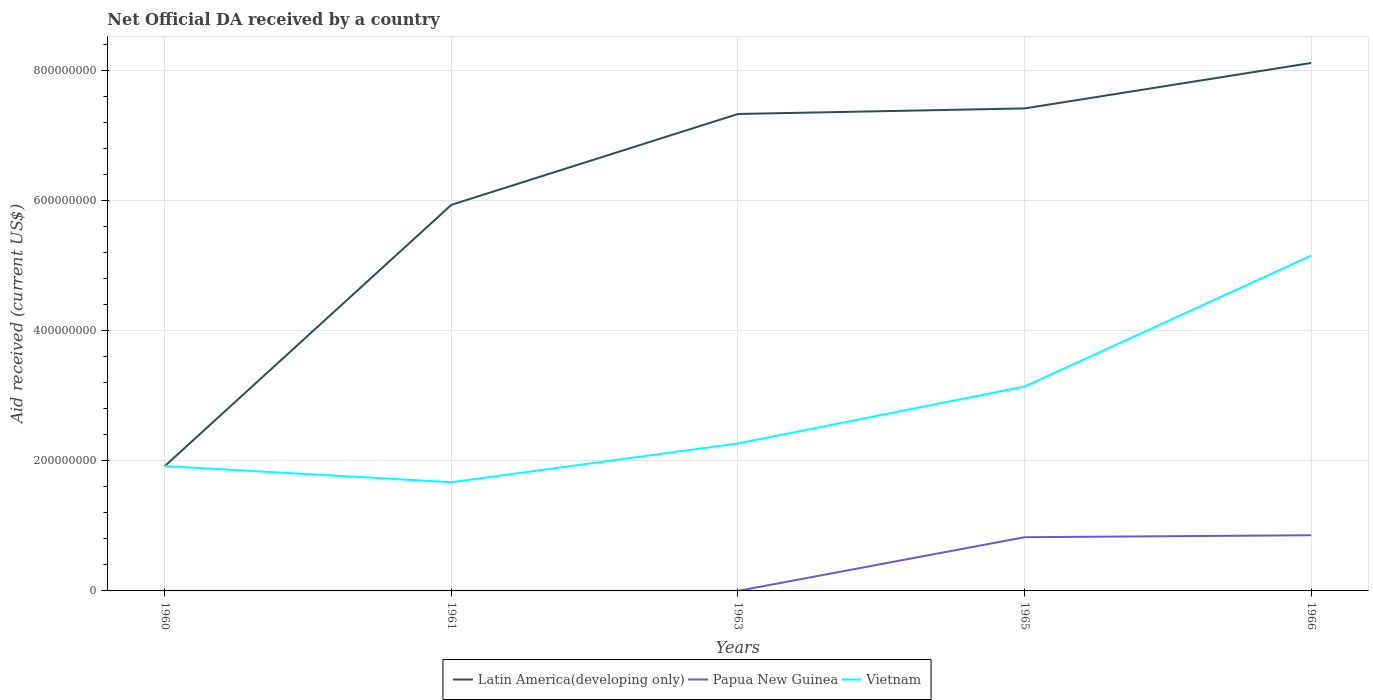Does the line corresponding to Vietnam intersect with the line corresponding to Latin America(developing only)?
Your answer should be very brief. No. Is the number of lines equal to the number of legend labels?
Make the answer very short. Yes. Across all years, what is the maximum net official development assistance aid received in Latin America(developing only)?
Your answer should be compact. 1.92e+08. In which year was the net official development assistance aid received in Papua New Guinea maximum?
Offer a very short reply. 1960. What is the total net official development assistance aid received in Latin America(developing only) in the graph?
Provide a succinct answer. -7.84e+07. What is the difference between the highest and the second highest net official development assistance aid received in Latin America(developing only)?
Give a very brief answer. 6.20e+08. What is the difference between the highest and the lowest net official development assistance aid received in Vietnam?
Your answer should be compact. 2. How many years are there in the graph?
Offer a very short reply. 5. What is the difference between two consecutive major ticks on the Y-axis?
Your response must be concise. 2.00e+08. Does the graph contain grids?
Provide a short and direct response. Yes. Where does the legend appear in the graph?
Your answer should be compact. Bottom center. How are the legend labels stacked?
Your response must be concise. Horizontal. What is the title of the graph?
Ensure brevity in your answer.  Net Official DA received by a country. What is the label or title of the X-axis?
Keep it short and to the point. Years. What is the label or title of the Y-axis?
Offer a terse response. Aid received (current US$). What is the Aid received (current US$) of Latin America(developing only) in 1960?
Make the answer very short. 1.92e+08. What is the Aid received (current US$) of Papua New Guinea in 1960?
Give a very brief answer. 10000. What is the Aid received (current US$) of Vietnam in 1960?
Provide a succinct answer. 1.92e+08. What is the Aid received (current US$) of Latin America(developing only) in 1961?
Your answer should be compact. 5.93e+08. What is the Aid received (current US$) of Papua New Guinea in 1961?
Your answer should be very brief. 10000. What is the Aid received (current US$) in Vietnam in 1961?
Your response must be concise. 1.67e+08. What is the Aid received (current US$) of Latin America(developing only) in 1963?
Your answer should be very brief. 7.33e+08. What is the Aid received (current US$) of Papua New Guinea in 1963?
Provide a succinct answer. 10000. What is the Aid received (current US$) in Vietnam in 1963?
Make the answer very short. 2.27e+08. What is the Aid received (current US$) of Latin America(developing only) in 1965?
Give a very brief answer. 7.42e+08. What is the Aid received (current US$) in Papua New Guinea in 1965?
Offer a very short reply. 8.26e+07. What is the Aid received (current US$) in Vietnam in 1965?
Your answer should be very brief. 3.14e+08. What is the Aid received (current US$) of Latin America(developing only) in 1966?
Your response must be concise. 8.12e+08. What is the Aid received (current US$) of Papua New Guinea in 1966?
Ensure brevity in your answer.  8.56e+07. What is the Aid received (current US$) of Vietnam in 1966?
Offer a very short reply. 5.15e+08. Across all years, what is the maximum Aid received (current US$) of Latin America(developing only)?
Keep it short and to the point. 8.12e+08. Across all years, what is the maximum Aid received (current US$) in Papua New Guinea?
Offer a very short reply. 8.56e+07. Across all years, what is the maximum Aid received (current US$) in Vietnam?
Your answer should be compact. 5.15e+08. Across all years, what is the minimum Aid received (current US$) in Latin America(developing only)?
Your answer should be very brief. 1.92e+08. Across all years, what is the minimum Aid received (current US$) in Papua New Guinea?
Your answer should be very brief. 10000. Across all years, what is the minimum Aid received (current US$) of Vietnam?
Provide a short and direct response. 1.67e+08. What is the total Aid received (current US$) in Latin America(developing only) in the graph?
Offer a terse response. 3.07e+09. What is the total Aid received (current US$) in Papua New Guinea in the graph?
Give a very brief answer. 1.68e+08. What is the total Aid received (current US$) of Vietnam in the graph?
Give a very brief answer. 1.42e+09. What is the difference between the Aid received (current US$) of Latin America(developing only) in 1960 and that in 1961?
Provide a short and direct response. -4.02e+08. What is the difference between the Aid received (current US$) of Vietnam in 1960 and that in 1961?
Offer a terse response. 2.47e+07. What is the difference between the Aid received (current US$) in Latin America(developing only) in 1960 and that in 1963?
Your response must be concise. -5.41e+08. What is the difference between the Aid received (current US$) of Papua New Guinea in 1960 and that in 1963?
Make the answer very short. 0. What is the difference between the Aid received (current US$) in Vietnam in 1960 and that in 1963?
Your answer should be very brief. -3.48e+07. What is the difference between the Aid received (current US$) of Latin America(developing only) in 1960 and that in 1965?
Give a very brief answer. -5.50e+08. What is the difference between the Aid received (current US$) in Papua New Guinea in 1960 and that in 1965?
Provide a short and direct response. -8.26e+07. What is the difference between the Aid received (current US$) of Vietnam in 1960 and that in 1965?
Offer a terse response. -1.22e+08. What is the difference between the Aid received (current US$) of Latin America(developing only) in 1960 and that in 1966?
Provide a short and direct response. -6.20e+08. What is the difference between the Aid received (current US$) of Papua New Guinea in 1960 and that in 1966?
Offer a terse response. -8.56e+07. What is the difference between the Aid received (current US$) of Vietnam in 1960 and that in 1966?
Keep it short and to the point. -3.24e+08. What is the difference between the Aid received (current US$) in Latin America(developing only) in 1961 and that in 1963?
Ensure brevity in your answer.  -1.40e+08. What is the difference between the Aid received (current US$) of Papua New Guinea in 1961 and that in 1963?
Offer a terse response. 0. What is the difference between the Aid received (current US$) in Vietnam in 1961 and that in 1963?
Offer a very short reply. -5.96e+07. What is the difference between the Aid received (current US$) in Latin America(developing only) in 1961 and that in 1965?
Your answer should be compact. -1.48e+08. What is the difference between the Aid received (current US$) of Papua New Guinea in 1961 and that in 1965?
Your response must be concise. -8.26e+07. What is the difference between the Aid received (current US$) of Vietnam in 1961 and that in 1965?
Give a very brief answer. -1.47e+08. What is the difference between the Aid received (current US$) in Latin America(developing only) in 1961 and that in 1966?
Make the answer very short. -2.18e+08. What is the difference between the Aid received (current US$) in Papua New Guinea in 1961 and that in 1966?
Provide a succinct answer. -8.56e+07. What is the difference between the Aid received (current US$) in Vietnam in 1961 and that in 1966?
Your answer should be compact. -3.48e+08. What is the difference between the Aid received (current US$) of Latin America(developing only) in 1963 and that in 1965?
Keep it short and to the point. -8.56e+06. What is the difference between the Aid received (current US$) of Papua New Guinea in 1963 and that in 1965?
Offer a terse response. -8.26e+07. What is the difference between the Aid received (current US$) in Vietnam in 1963 and that in 1965?
Offer a terse response. -8.75e+07. What is the difference between the Aid received (current US$) in Latin America(developing only) in 1963 and that in 1966?
Your answer should be very brief. -7.84e+07. What is the difference between the Aid received (current US$) in Papua New Guinea in 1963 and that in 1966?
Make the answer very short. -8.56e+07. What is the difference between the Aid received (current US$) of Vietnam in 1963 and that in 1966?
Your answer should be very brief. -2.89e+08. What is the difference between the Aid received (current US$) of Latin America(developing only) in 1965 and that in 1966?
Offer a terse response. -6.98e+07. What is the difference between the Aid received (current US$) of Papua New Guinea in 1965 and that in 1966?
Provide a short and direct response. -3.03e+06. What is the difference between the Aid received (current US$) in Vietnam in 1965 and that in 1966?
Provide a short and direct response. -2.01e+08. What is the difference between the Aid received (current US$) in Latin America(developing only) in 1960 and the Aid received (current US$) in Papua New Guinea in 1961?
Give a very brief answer. 1.92e+08. What is the difference between the Aid received (current US$) in Latin America(developing only) in 1960 and the Aid received (current US$) in Vietnam in 1961?
Offer a terse response. 2.48e+07. What is the difference between the Aid received (current US$) in Papua New Guinea in 1960 and the Aid received (current US$) in Vietnam in 1961?
Your answer should be very brief. -1.67e+08. What is the difference between the Aid received (current US$) in Latin America(developing only) in 1960 and the Aid received (current US$) in Papua New Guinea in 1963?
Your response must be concise. 1.92e+08. What is the difference between the Aid received (current US$) in Latin America(developing only) in 1960 and the Aid received (current US$) in Vietnam in 1963?
Give a very brief answer. -3.48e+07. What is the difference between the Aid received (current US$) of Papua New Guinea in 1960 and the Aid received (current US$) of Vietnam in 1963?
Offer a terse response. -2.27e+08. What is the difference between the Aid received (current US$) in Latin America(developing only) in 1960 and the Aid received (current US$) in Papua New Guinea in 1965?
Your response must be concise. 1.09e+08. What is the difference between the Aid received (current US$) of Latin America(developing only) in 1960 and the Aid received (current US$) of Vietnam in 1965?
Ensure brevity in your answer.  -1.22e+08. What is the difference between the Aid received (current US$) in Papua New Guinea in 1960 and the Aid received (current US$) in Vietnam in 1965?
Make the answer very short. -3.14e+08. What is the difference between the Aid received (current US$) of Latin America(developing only) in 1960 and the Aid received (current US$) of Papua New Guinea in 1966?
Provide a succinct answer. 1.06e+08. What is the difference between the Aid received (current US$) in Latin America(developing only) in 1960 and the Aid received (current US$) in Vietnam in 1966?
Offer a terse response. -3.23e+08. What is the difference between the Aid received (current US$) of Papua New Guinea in 1960 and the Aid received (current US$) of Vietnam in 1966?
Provide a succinct answer. -5.15e+08. What is the difference between the Aid received (current US$) in Latin America(developing only) in 1961 and the Aid received (current US$) in Papua New Guinea in 1963?
Your answer should be compact. 5.93e+08. What is the difference between the Aid received (current US$) of Latin America(developing only) in 1961 and the Aid received (current US$) of Vietnam in 1963?
Your answer should be compact. 3.67e+08. What is the difference between the Aid received (current US$) in Papua New Guinea in 1961 and the Aid received (current US$) in Vietnam in 1963?
Offer a terse response. -2.27e+08. What is the difference between the Aid received (current US$) in Latin America(developing only) in 1961 and the Aid received (current US$) in Papua New Guinea in 1965?
Offer a very short reply. 5.11e+08. What is the difference between the Aid received (current US$) of Latin America(developing only) in 1961 and the Aid received (current US$) of Vietnam in 1965?
Make the answer very short. 2.79e+08. What is the difference between the Aid received (current US$) in Papua New Guinea in 1961 and the Aid received (current US$) in Vietnam in 1965?
Ensure brevity in your answer.  -3.14e+08. What is the difference between the Aid received (current US$) of Latin America(developing only) in 1961 and the Aid received (current US$) of Papua New Guinea in 1966?
Keep it short and to the point. 5.08e+08. What is the difference between the Aid received (current US$) in Latin America(developing only) in 1961 and the Aid received (current US$) in Vietnam in 1966?
Provide a short and direct response. 7.81e+07. What is the difference between the Aid received (current US$) in Papua New Guinea in 1961 and the Aid received (current US$) in Vietnam in 1966?
Offer a terse response. -5.15e+08. What is the difference between the Aid received (current US$) of Latin America(developing only) in 1963 and the Aid received (current US$) of Papua New Guinea in 1965?
Offer a terse response. 6.51e+08. What is the difference between the Aid received (current US$) of Latin America(developing only) in 1963 and the Aid received (current US$) of Vietnam in 1965?
Your answer should be compact. 4.19e+08. What is the difference between the Aid received (current US$) in Papua New Guinea in 1963 and the Aid received (current US$) in Vietnam in 1965?
Give a very brief answer. -3.14e+08. What is the difference between the Aid received (current US$) of Latin America(developing only) in 1963 and the Aid received (current US$) of Papua New Guinea in 1966?
Offer a terse response. 6.48e+08. What is the difference between the Aid received (current US$) of Latin America(developing only) in 1963 and the Aid received (current US$) of Vietnam in 1966?
Offer a terse response. 2.18e+08. What is the difference between the Aid received (current US$) in Papua New Guinea in 1963 and the Aid received (current US$) in Vietnam in 1966?
Your response must be concise. -5.15e+08. What is the difference between the Aid received (current US$) in Latin America(developing only) in 1965 and the Aid received (current US$) in Papua New Guinea in 1966?
Your response must be concise. 6.56e+08. What is the difference between the Aid received (current US$) of Latin America(developing only) in 1965 and the Aid received (current US$) of Vietnam in 1966?
Ensure brevity in your answer.  2.26e+08. What is the difference between the Aid received (current US$) in Papua New Guinea in 1965 and the Aid received (current US$) in Vietnam in 1966?
Offer a very short reply. -4.33e+08. What is the average Aid received (current US$) of Latin America(developing only) per year?
Make the answer very short. 6.14e+08. What is the average Aid received (current US$) in Papua New Guinea per year?
Give a very brief answer. 3.36e+07. What is the average Aid received (current US$) in Vietnam per year?
Make the answer very short. 2.83e+08. In the year 1960, what is the difference between the Aid received (current US$) of Latin America(developing only) and Aid received (current US$) of Papua New Guinea?
Provide a short and direct response. 1.92e+08. In the year 1960, what is the difference between the Aid received (current US$) in Latin America(developing only) and Aid received (current US$) in Vietnam?
Ensure brevity in your answer.  4.00e+04. In the year 1960, what is the difference between the Aid received (current US$) in Papua New Guinea and Aid received (current US$) in Vietnam?
Make the answer very short. -1.92e+08. In the year 1961, what is the difference between the Aid received (current US$) of Latin America(developing only) and Aid received (current US$) of Papua New Guinea?
Make the answer very short. 5.93e+08. In the year 1961, what is the difference between the Aid received (current US$) in Latin America(developing only) and Aid received (current US$) in Vietnam?
Give a very brief answer. 4.26e+08. In the year 1961, what is the difference between the Aid received (current US$) in Papua New Guinea and Aid received (current US$) in Vietnam?
Ensure brevity in your answer.  -1.67e+08. In the year 1963, what is the difference between the Aid received (current US$) of Latin America(developing only) and Aid received (current US$) of Papua New Guinea?
Provide a succinct answer. 7.33e+08. In the year 1963, what is the difference between the Aid received (current US$) of Latin America(developing only) and Aid received (current US$) of Vietnam?
Give a very brief answer. 5.06e+08. In the year 1963, what is the difference between the Aid received (current US$) in Papua New Guinea and Aid received (current US$) in Vietnam?
Provide a short and direct response. -2.27e+08. In the year 1965, what is the difference between the Aid received (current US$) in Latin America(developing only) and Aid received (current US$) in Papua New Guinea?
Provide a short and direct response. 6.59e+08. In the year 1965, what is the difference between the Aid received (current US$) in Latin America(developing only) and Aid received (current US$) in Vietnam?
Offer a terse response. 4.28e+08. In the year 1965, what is the difference between the Aid received (current US$) in Papua New Guinea and Aid received (current US$) in Vietnam?
Provide a short and direct response. -2.32e+08. In the year 1966, what is the difference between the Aid received (current US$) in Latin America(developing only) and Aid received (current US$) in Papua New Guinea?
Make the answer very short. 7.26e+08. In the year 1966, what is the difference between the Aid received (current US$) of Latin America(developing only) and Aid received (current US$) of Vietnam?
Provide a short and direct response. 2.96e+08. In the year 1966, what is the difference between the Aid received (current US$) in Papua New Guinea and Aid received (current US$) in Vietnam?
Ensure brevity in your answer.  -4.30e+08. What is the ratio of the Aid received (current US$) of Latin America(developing only) in 1960 to that in 1961?
Ensure brevity in your answer.  0.32. What is the ratio of the Aid received (current US$) of Papua New Guinea in 1960 to that in 1961?
Provide a succinct answer. 1. What is the ratio of the Aid received (current US$) of Vietnam in 1960 to that in 1961?
Provide a short and direct response. 1.15. What is the ratio of the Aid received (current US$) in Latin America(developing only) in 1960 to that in 1963?
Keep it short and to the point. 0.26. What is the ratio of the Aid received (current US$) in Papua New Guinea in 1960 to that in 1963?
Make the answer very short. 1. What is the ratio of the Aid received (current US$) in Vietnam in 1960 to that in 1963?
Your answer should be very brief. 0.85. What is the ratio of the Aid received (current US$) of Latin America(developing only) in 1960 to that in 1965?
Offer a very short reply. 0.26. What is the ratio of the Aid received (current US$) of Vietnam in 1960 to that in 1965?
Provide a short and direct response. 0.61. What is the ratio of the Aid received (current US$) of Latin America(developing only) in 1960 to that in 1966?
Offer a terse response. 0.24. What is the ratio of the Aid received (current US$) of Vietnam in 1960 to that in 1966?
Provide a succinct answer. 0.37. What is the ratio of the Aid received (current US$) in Latin America(developing only) in 1961 to that in 1963?
Make the answer very short. 0.81. What is the ratio of the Aid received (current US$) of Papua New Guinea in 1961 to that in 1963?
Ensure brevity in your answer.  1. What is the ratio of the Aid received (current US$) in Vietnam in 1961 to that in 1963?
Ensure brevity in your answer.  0.74. What is the ratio of the Aid received (current US$) of Latin America(developing only) in 1961 to that in 1965?
Provide a short and direct response. 0.8. What is the ratio of the Aid received (current US$) in Vietnam in 1961 to that in 1965?
Give a very brief answer. 0.53. What is the ratio of the Aid received (current US$) of Latin America(developing only) in 1961 to that in 1966?
Your answer should be compact. 0.73. What is the ratio of the Aid received (current US$) in Papua New Guinea in 1961 to that in 1966?
Provide a short and direct response. 0. What is the ratio of the Aid received (current US$) of Vietnam in 1961 to that in 1966?
Offer a very short reply. 0.32. What is the ratio of the Aid received (current US$) in Vietnam in 1963 to that in 1965?
Offer a very short reply. 0.72. What is the ratio of the Aid received (current US$) in Latin America(developing only) in 1963 to that in 1966?
Ensure brevity in your answer.  0.9. What is the ratio of the Aid received (current US$) in Vietnam in 1963 to that in 1966?
Offer a very short reply. 0.44. What is the ratio of the Aid received (current US$) in Latin America(developing only) in 1965 to that in 1966?
Your answer should be compact. 0.91. What is the ratio of the Aid received (current US$) of Papua New Guinea in 1965 to that in 1966?
Make the answer very short. 0.96. What is the ratio of the Aid received (current US$) in Vietnam in 1965 to that in 1966?
Offer a terse response. 0.61. What is the difference between the highest and the second highest Aid received (current US$) in Latin America(developing only)?
Provide a short and direct response. 6.98e+07. What is the difference between the highest and the second highest Aid received (current US$) of Papua New Guinea?
Your answer should be compact. 3.03e+06. What is the difference between the highest and the second highest Aid received (current US$) in Vietnam?
Your response must be concise. 2.01e+08. What is the difference between the highest and the lowest Aid received (current US$) in Latin America(developing only)?
Provide a succinct answer. 6.20e+08. What is the difference between the highest and the lowest Aid received (current US$) of Papua New Guinea?
Provide a short and direct response. 8.56e+07. What is the difference between the highest and the lowest Aid received (current US$) in Vietnam?
Provide a short and direct response. 3.48e+08. 